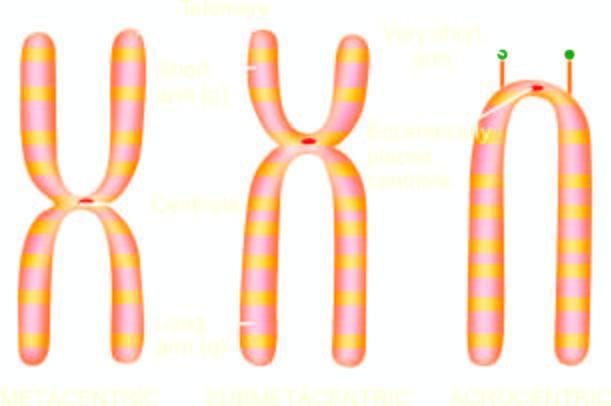what is based on size and location of centromere?
Answer the question using a single word or phrase. Classification chromosomes 